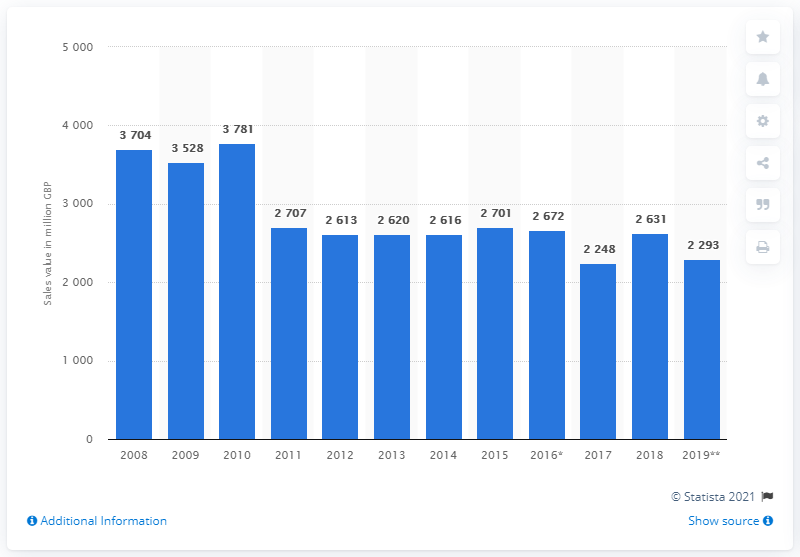Indicate a few pertinent items in this graphic. In 2019, the value of cocoa, chocolate, and sugar confectionery sold in the UK was approximately 2,293 million GBP. 